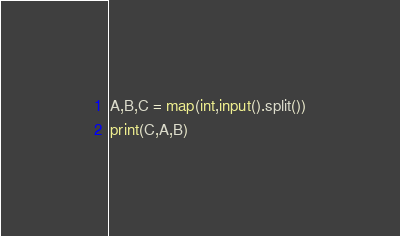Convert code to text. <code><loc_0><loc_0><loc_500><loc_500><_Python_>A,B,C = map(int,input().split())
print(C,A,B)</code> 